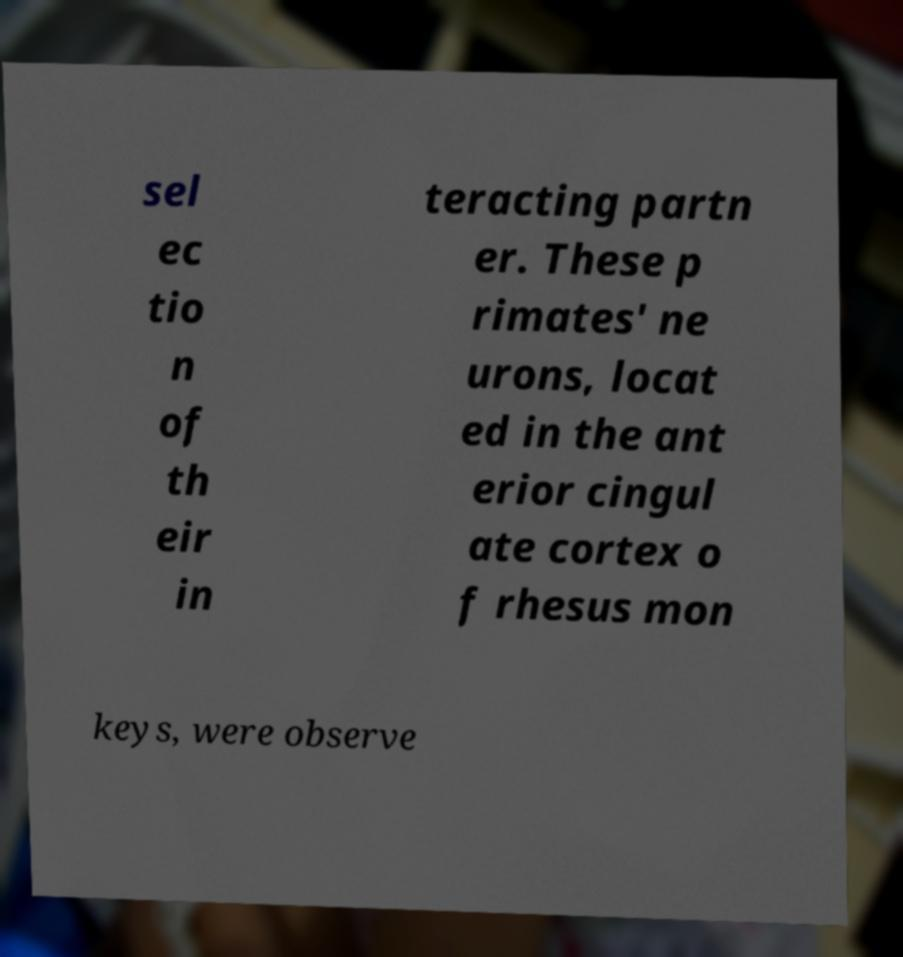Can you accurately transcribe the text from the provided image for me? sel ec tio n of th eir in teracting partn er. These p rimates' ne urons, locat ed in the ant erior cingul ate cortex o f rhesus mon keys, were observe 